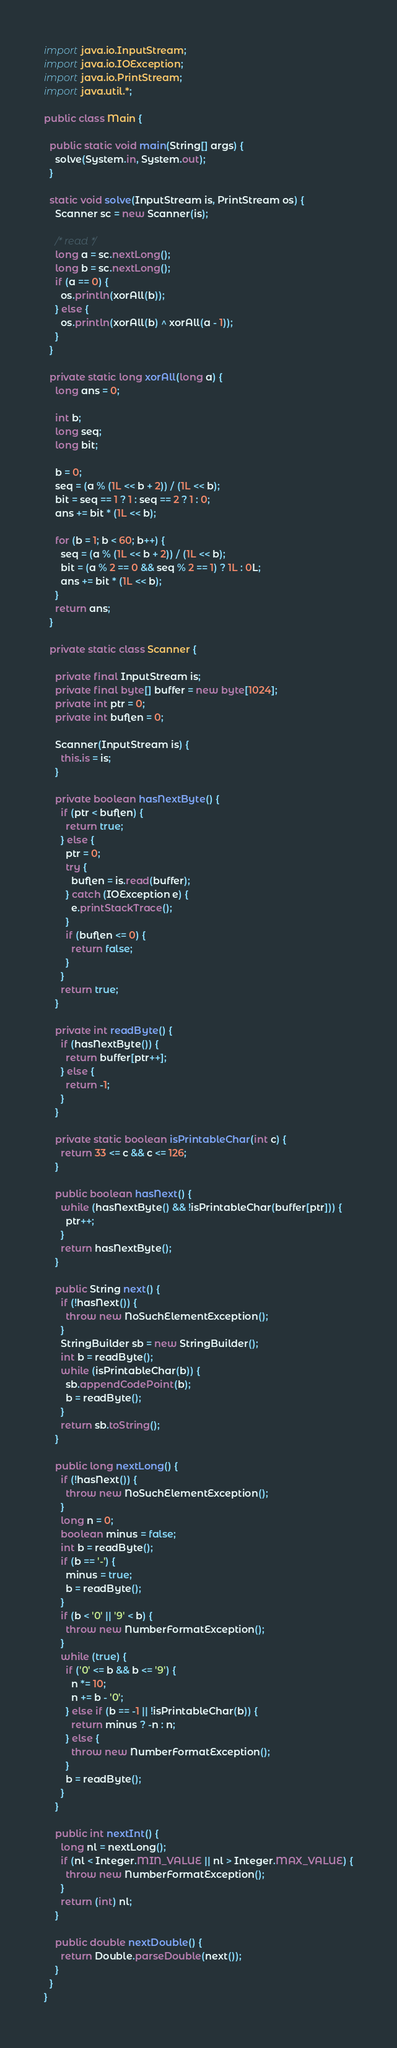Convert code to text. <code><loc_0><loc_0><loc_500><loc_500><_Java_>import java.io.InputStream;
import java.io.IOException;
import java.io.PrintStream;
import java.util.*;

public class Main {

  public static void main(String[] args) {
    solve(System.in, System.out);
  }

  static void solve(InputStream is, PrintStream os) {
    Scanner sc = new Scanner(is);

    /* read */
    long a = sc.nextLong();
    long b = sc.nextLong();
    if (a == 0) {
      os.println(xorAll(b));
    } else {
      os.println(xorAll(b) ^ xorAll(a - 1));
    }
  }

  private static long xorAll(long a) {
    long ans = 0;

    int b;
    long seq;
    long bit;

    b = 0;
    seq = (a % (1L << b + 2)) / (1L << b);
    bit = seq == 1 ? 1 : seq == 2 ? 1 : 0;
    ans += bit * (1L << b);

    for (b = 1; b < 60; b++) {
      seq = (a % (1L << b + 2)) / (1L << b);
      bit = (a % 2 == 0 && seq % 2 == 1) ? 1L : 0L;
      ans += bit * (1L << b);
    }
    return ans;
  }

  private static class Scanner {

    private final InputStream is;
    private final byte[] buffer = new byte[1024];
    private int ptr = 0;
    private int buflen = 0;

    Scanner(InputStream is) {
      this.is = is;
    }

    private boolean hasNextByte() {
      if (ptr < buflen) {
        return true;
      } else {
        ptr = 0;
        try {
          buflen = is.read(buffer);
        } catch (IOException e) {
          e.printStackTrace();
        }
        if (buflen <= 0) {
          return false;
        }
      }
      return true;
    }

    private int readByte() {
      if (hasNextByte()) {
        return buffer[ptr++];
      } else {
        return -1;
      }
    }

    private static boolean isPrintableChar(int c) {
      return 33 <= c && c <= 126;
    }

    public boolean hasNext() {
      while (hasNextByte() && !isPrintableChar(buffer[ptr])) {
        ptr++;
      }
      return hasNextByte();
    }

    public String next() {
      if (!hasNext()) {
        throw new NoSuchElementException();
      }
      StringBuilder sb = new StringBuilder();
      int b = readByte();
      while (isPrintableChar(b)) {
        sb.appendCodePoint(b);
        b = readByte();
      }
      return sb.toString();
    }

    public long nextLong() {
      if (!hasNext()) {
        throw new NoSuchElementException();
      }
      long n = 0;
      boolean minus = false;
      int b = readByte();
      if (b == '-') {
        minus = true;
        b = readByte();
      }
      if (b < '0' || '9' < b) {
        throw new NumberFormatException();
      }
      while (true) {
        if ('0' <= b && b <= '9') {
          n *= 10;
          n += b - '0';
        } else if (b == -1 || !isPrintableChar(b)) {
          return minus ? -n : n;
        } else {
          throw new NumberFormatException();
        }
        b = readByte();
      }
    }

    public int nextInt() {
      long nl = nextLong();
      if (nl < Integer.MIN_VALUE || nl > Integer.MAX_VALUE) {
        throw new NumberFormatException();
      }
      return (int) nl;
    }

    public double nextDouble() {
      return Double.parseDouble(next());
    }
  }
}
</code> 